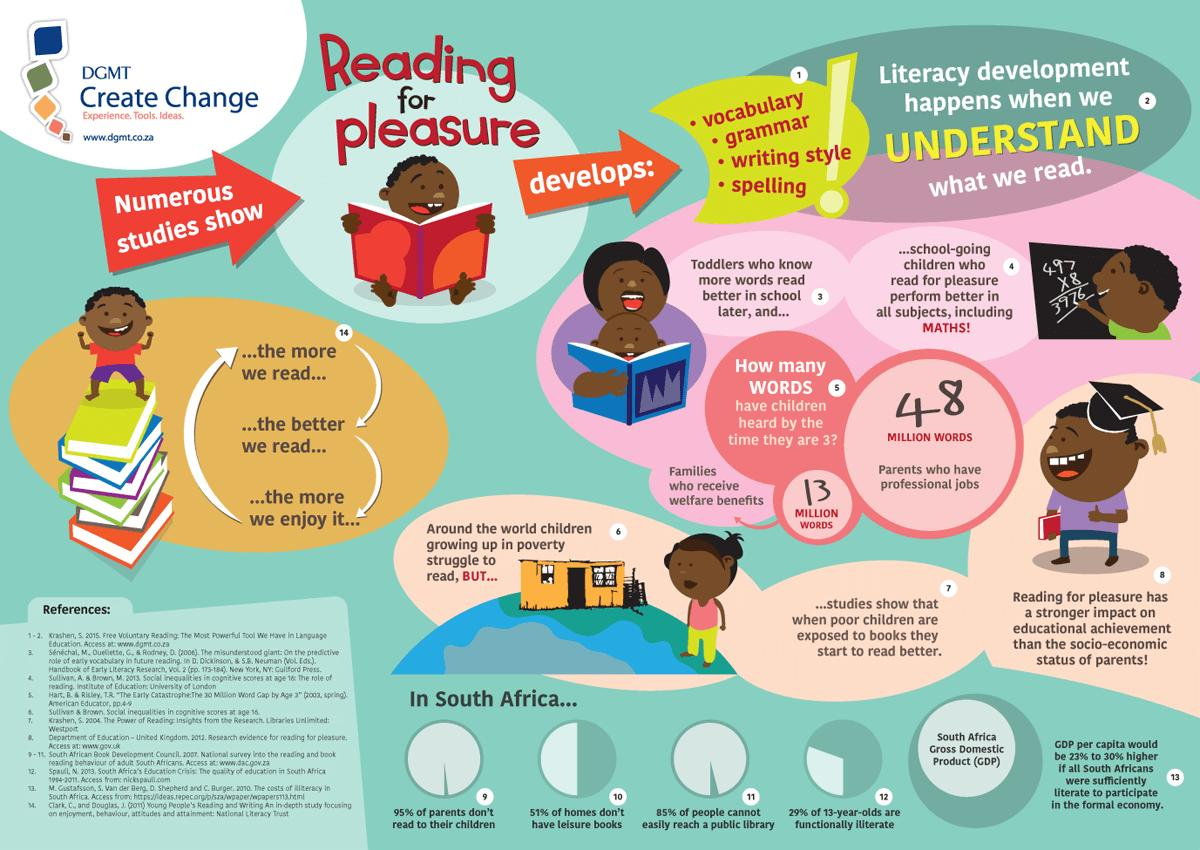Indicate a few pertinent items in this graphic. According to a study, children belonging to families who receive welfare benefits have heard approximately 13 million words by the age of 3. According to a recent survey in South Africa, only 5% of parents read to their children on a daily basis. The total written on the blackboard is 3976. In South Africa, it is estimated that approximately 15% of the population has easy access to a public library. Reading for pleasure is essential in the development of vocabulary, grammar, writing style, and spelling. 